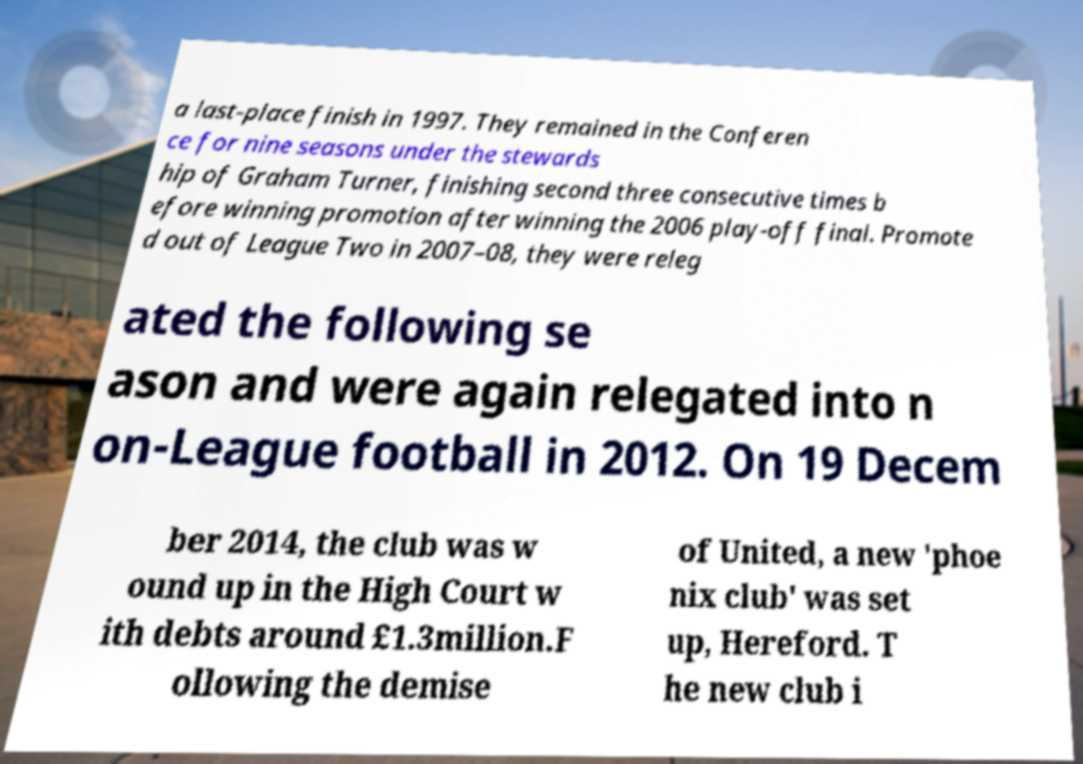Please read and relay the text visible in this image. What does it say? a last-place finish in 1997. They remained in the Conferen ce for nine seasons under the stewards hip of Graham Turner, finishing second three consecutive times b efore winning promotion after winning the 2006 play-off final. Promote d out of League Two in 2007–08, they were releg ated the following se ason and were again relegated into n on-League football in 2012. On 19 Decem ber 2014, the club was w ound up in the High Court w ith debts around £1.3million.F ollowing the demise of United, a new 'phoe nix club' was set up, Hereford. T he new club i 